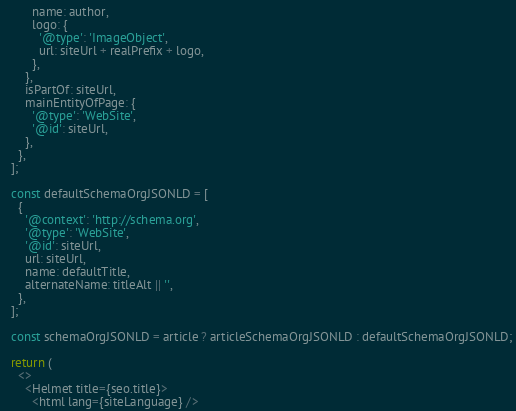<code> <loc_0><loc_0><loc_500><loc_500><_JavaScript_>        name: author,
        logo: {
          '@type': 'ImageObject',
          url: siteUrl + realPrefix + logo,
        },
      },
      isPartOf: siteUrl,
      mainEntityOfPage: {
        '@type': 'WebSite',
        '@id': siteUrl,
      },
    },
  ];

  const defaultSchemaOrgJSONLD = [
    {
      '@context': 'http://schema.org',
      '@type': 'WebSite',
      '@id': siteUrl,
      url: siteUrl,
      name: defaultTitle,
      alternateName: titleAlt || '',
    },
  ];

  const schemaOrgJSONLD = article ? articleSchemaOrgJSONLD : defaultSchemaOrgJSONLD;

  return (
    <>
      <Helmet title={seo.title}>
        <html lang={siteLanguage} />
</code> 